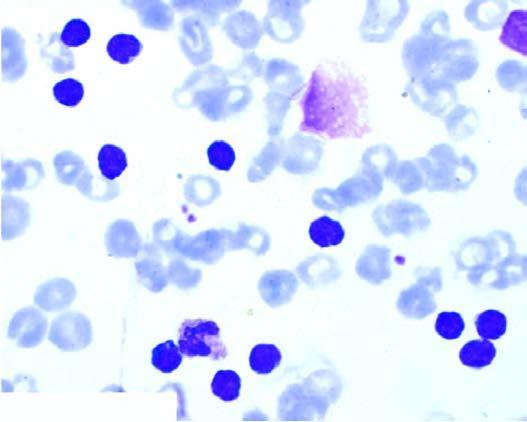s the cytoplasm large excess of mature and small differentiated lymphocytes?
Answer the question using a single word or phrase. No 